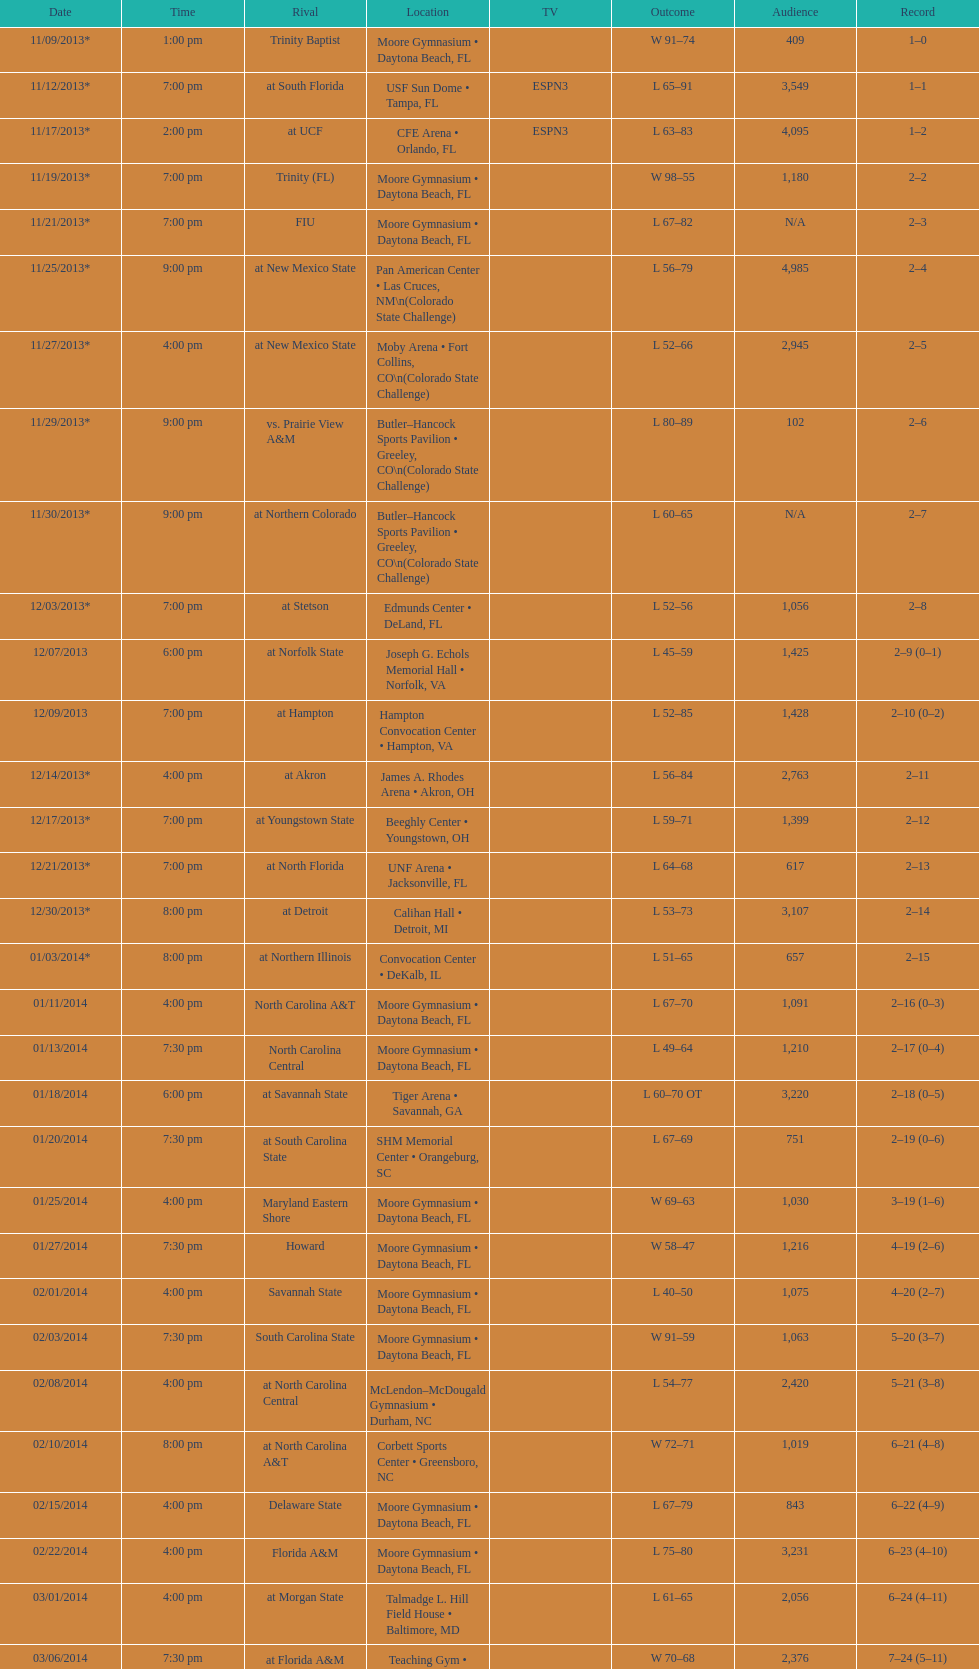Was the attendance of the game held on 11/19/2013 greater than 1,000? Yes. 